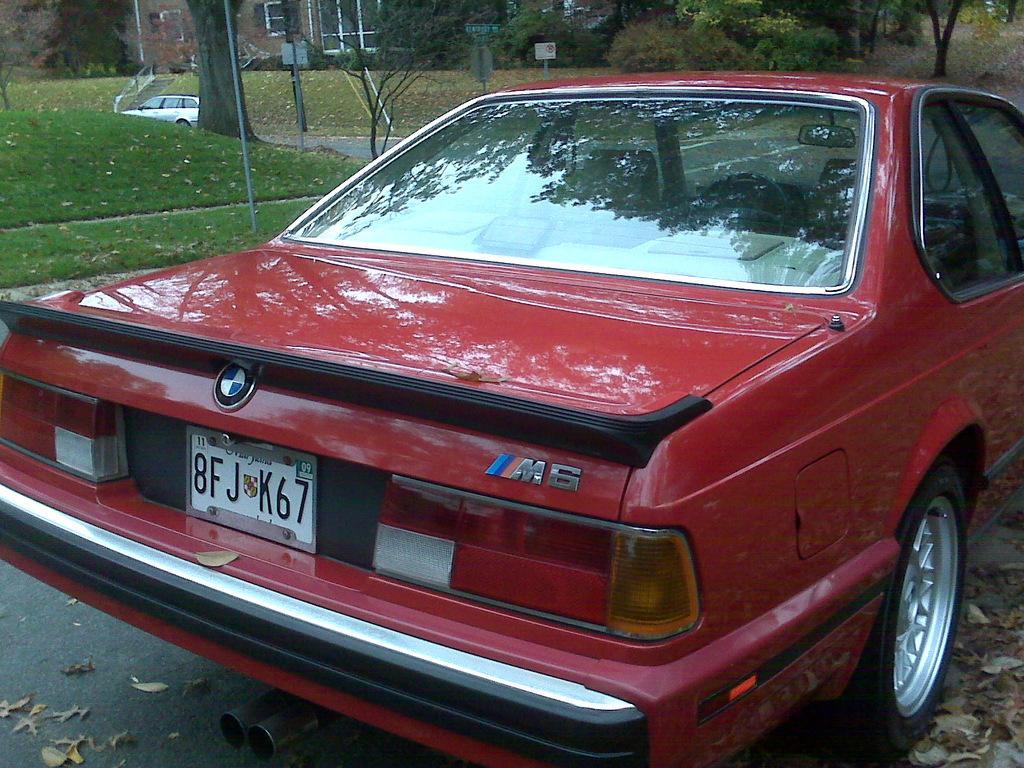In one or two sentences, can you explain what this image depicts? Here we can see a car on the road. In the background there is a vehicle,trees,poles,building,grass and windows. 